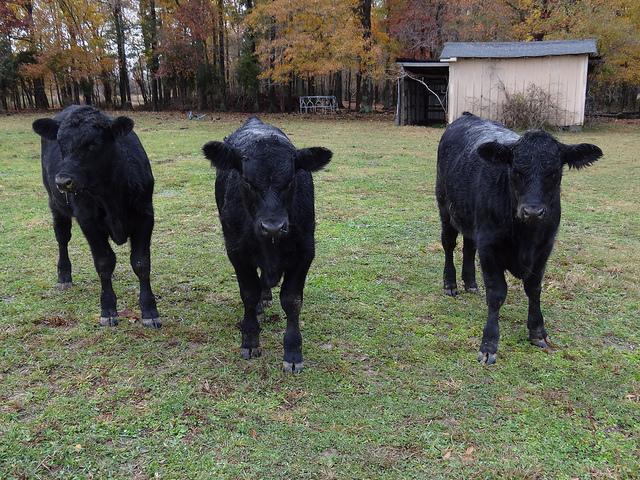How many cows are standing in the pasture field?
Choose the correct response, then elucidate: 'Answer: answer
Rationale: rationale.'
Options: Five, two, three, four. Answer: three.
Rationale: A group of cows is standing in an open area. 